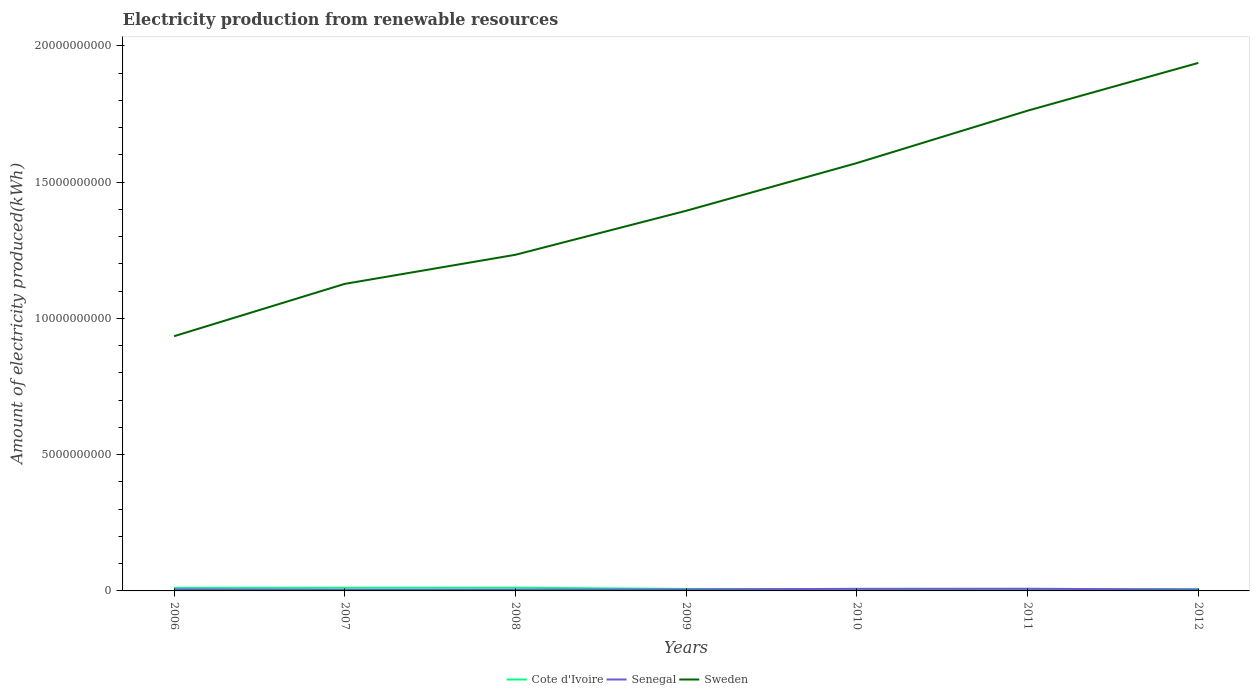How many different coloured lines are there?
Give a very brief answer. 3. Across all years, what is the maximum amount of electricity produced in Senegal?
Your response must be concise. 4.00e+07. In which year was the amount of electricity produced in Senegal maximum?
Provide a short and direct response. 2007. What is the total amount of electricity produced in Sweden in the graph?
Your answer should be very brief. -3.68e+09. What is the difference between the highest and the second highest amount of electricity produced in Senegal?
Offer a terse response. 4.00e+07. What is the difference between the highest and the lowest amount of electricity produced in Cote d'Ivoire?
Provide a short and direct response. 3. Is the amount of electricity produced in Sweden strictly greater than the amount of electricity produced in Cote d'Ivoire over the years?
Your response must be concise. No. How many years are there in the graph?
Offer a very short reply. 7. What is the difference between two consecutive major ticks on the Y-axis?
Provide a short and direct response. 5.00e+09. Are the values on the major ticks of Y-axis written in scientific E-notation?
Make the answer very short. No. What is the title of the graph?
Provide a short and direct response. Electricity production from renewable resources. What is the label or title of the Y-axis?
Provide a short and direct response. Amount of electricity produced(kWh). What is the Amount of electricity produced(kWh) of Cote d'Ivoire in 2006?
Provide a short and direct response. 1.12e+08. What is the Amount of electricity produced(kWh) of Senegal in 2006?
Offer a very short reply. 5.50e+07. What is the Amount of electricity produced(kWh) in Sweden in 2006?
Give a very brief answer. 9.35e+09. What is the Amount of electricity produced(kWh) in Cote d'Ivoire in 2007?
Your response must be concise. 1.15e+08. What is the Amount of electricity produced(kWh) in Senegal in 2007?
Your answer should be compact. 4.00e+07. What is the Amount of electricity produced(kWh) of Sweden in 2007?
Your answer should be very brief. 1.13e+1. What is the Amount of electricity produced(kWh) in Cote d'Ivoire in 2008?
Provide a succinct answer. 1.18e+08. What is the Amount of electricity produced(kWh) in Senegal in 2008?
Your answer should be compact. 4.30e+07. What is the Amount of electricity produced(kWh) in Sweden in 2008?
Offer a terse response. 1.23e+1. What is the Amount of electricity produced(kWh) in Cote d'Ivoire in 2009?
Keep it short and to the point. 7.20e+07. What is the Amount of electricity produced(kWh) of Senegal in 2009?
Ensure brevity in your answer.  5.30e+07. What is the Amount of electricity produced(kWh) of Sweden in 2009?
Provide a short and direct response. 1.40e+1. What is the Amount of electricity produced(kWh) in Cote d'Ivoire in 2010?
Your answer should be very brief. 6.90e+07. What is the Amount of electricity produced(kWh) in Senegal in 2010?
Your response must be concise. 7.70e+07. What is the Amount of electricity produced(kWh) in Sweden in 2010?
Your answer should be very brief. 1.57e+1. What is the Amount of electricity produced(kWh) of Cote d'Ivoire in 2011?
Provide a succinct answer. 6.40e+07. What is the Amount of electricity produced(kWh) in Senegal in 2011?
Keep it short and to the point. 8.00e+07. What is the Amount of electricity produced(kWh) in Sweden in 2011?
Offer a terse response. 1.76e+1. What is the Amount of electricity produced(kWh) of Cote d'Ivoire in 2012?
Make the answer very short. 6.60e+07. What is the Amount of electricity produced(kWh) in Senegal in 2012?
Offer a terse response. 4.90e+07. What is the Amount of electricity produced(kWh) in Sweden in 2012?
Make the answer very short. 1.94e+1. Across all years, what is the maximum Amount of electricity produced(kWh) in Cote d'Ivoire?
Offer a very short reply. 1.18e+08. Across all years, what is the maximum Amount of electricity produced(kWh) in Senegal?
Your answer should be compact. 8.00e+07. Across all years, what is the maximum Amount of electricity produced(kWh) of Sweden?
Provide a short and direct response. 1.94e+1. Across all years, what is the minimum Amount of electricity produced(kWh) in Cote d'Ivoire?
Provide a succinct answer. 6.40e+07. Across all years, what is the minimum Amount of electricity produced(kWh) of Senegal?
Keep it short and to the point. 4.00e+07. Across all years, what is the minimum Amount of electricity produced(kWh) of Sweden?
Provide a short and direct response. 9.35e+09. What is the total Amount of electricity produced(kWh) in Cote d'Ivoire in the graph?
Keep it short and to the point. 6.16e+08. What is the total Amount of electricity produced(kWh) in Senegal in the graph?
Offer a very short reply. 3.97e+08. What is the total Amount of electricity produced(kWh) of Sweden in the graph?
Ensure brevity in your answer.  9.96e+1. What is the difference between the Amount of electricity produced(kWh) in Cote d'Ivoire in 2006 and that in 2007?
Your response must be concise. -3.00e+06. What is the difference between the Amount of electricity produced(kWh) in Senegal in 2006 and that in 2007?
Offer a very short reply. 1.50e+07. What is the difference between the Amount of electricity produced(kWh) of Sweden in 2006 and that in 2007?
Offer a very short reply. -1.92e+09. What is the difference between the Amount of electricity produced(kWh) in Cote d'Ivoire in 2006 and that in 2008?
Offer a terse response. -6.00e+06. What is the difference between the Amount of electricity produced(kWh) in Sweden in 2006 and that in 2008?
Give a very brief answer. -2.99e+09. What is the difference between the Amount of electricity produced(kWh) of Cote d'Ivoire in 2006 and that in 2009?
Provide a succinct answer. 4.00e+07. What is the difference between the Amount of electricity produced(kWh) in Senegal in 2006 and that in 2009?
Your answer should be very brief. 2.00e+06. What is the difference between the Amount of electricity produced(kWh) of Sweden in 2006 and that in 2009?
Offer a terse response. -4.60e+09. What is the difference between the Amount of electricity produced(kWh) in Cote d'Ivoire in 2006 and that in 2010?
Ensure brevity in your answer.  4.30e+07. What is the difference between the Amount of electricity produced(kWh) of Senegal in 2006 and that in 2010?
Your response must be concise. -2.20e+07. What is the difference between the Amount of electricity produced(kWh) of Sweden in 2006 and that in 2010?
Make the answer very short. -6.36e+09. What is the difference between the Amount of electricity produced(kWh) in Cote d'Ivoire in 2006 and that in 2011?
Offer a very short reply. 4.80e+07. What is the difference between the Amount of electricity produced(kWh) in Senegal in 2006 and that in 2011?
Provide a short and direct response. -2.50e+07. What is the difference between the Amount of electricity produced(kWh) of Sweden in 2006 and that in 2011?
Offer a very short reply. -8.28e+09. What is the difference between the Amount of electricity produced(kWh) in Cote d'Ivoire in 2006 and that in 2012?
Ensure brevity in your answer.  4.60e+07. What is the difference between the Amount of electricity produced(kWh) of Sweden in 2006 and that in 2012?
Ensure brevity in your answer.  -1.00e+1. What is the difference between the Amount of electricity produced(kWh) in Cote d'Ivoire in 2007 and that in 2008?
Give a very brief answer. -3.00e+06. What is the difference between the Amount of electricity produced(kWh) in Sweden in 2007 and that in 2008?
Provide a short and direct response. -1.07e+09. What is the difference between the Amount of electricity produced(kWh) in Cote d'Ivoire in 2007 and that in 2009?
Your response must be concise. 4.30e+07. What is the difference between the Amount of electricity produced(kWh) of Senegal in 2007 and that in 2009?
Your response must be concise. -1.30e+07. What is the difference between the Amount of electricity produced(kWh) of Sweden in 2007 and that in 2009?
Offer a very short reply. -2.68e+09. What is the difference between the Amount of electricity produced(kWh) of Cote d'Ivoire in 2007 and that in 2010?
Your answer should be compact. 4.60e+07. What is the difference between the Amount of electricity produced(kWh) in Senegal in 2007 and that in 2010?
Give a very brief answer. -3.70e+07. What is the difference between the Amount of electricity produced(kWh) of Sweden in 2007 and that in 2010?
Provide a succinct answer. -4.43e+09. What is the difference between the Amount of electricity produced(kWh) of Cote d'Ivoire in 2007 and that in 2011?
Provide a short and direct response. 5.10e+07. What is the difference between the Amount of electricity produced(kWh) of Senegal in 2007 and that in 2011?
Offer a terse response. -4.00e+07. What is the difference between the Amount of electricity produced(kWh) of Sweden in 2007 and that in 2011?
Your answer should be very brief. -6.36e+09. What is the difference between the Amount of electricity produced(kWh) in Cote d'Ivoire in 2007 and that in 2012?
Your response must be concise. 4.90e+07. What is the difference between the Amount of electricity produced(kWh) in Senegal in 2007 and that in 2012?
Provide a succinct answer. -9.00e+06. What is the difference between the Amount of electricity produced(kWh) in Sweden in 2007 and that in 2012?
Provide a short and direct response. -8.11e+09. What is the difference between the Amount of electricity produced(kWh) in Cote d'Ivoire in 2008 and that in 2009?
Your answer should be compact. 4.60e+07. What is the difference between the Amount of electricity produced(kWh) in Senegal in 2008 and that in 2009?
Make the answer very short. -1.00e+07. What is the difference between the Amount of electricity produced(kWh) of Sweden in 2008 and that in 2009?
Your response must be concise. -1.62e+09. What is the difference between the Amount of electricity produced(kWh) of Cote d'Ivoire in 2008 and that in 2010?
Offer a very short reply. 4.90e+07. What is the difference between the Amount of electricity produced(kWh) of Senegal in 2008 and that in 2010?
Offer a terse response. -3.40e+07. What is the difference between the Amount of electricity produced(kWh) in Sweden in 2008 and that in 2010?
Offer a terse response. -3.37e+09. What is the difference between the Amount of electricity produced(kWh) in Cote d'Ivoire in 2008 and that in 2011?
Ensure brevity in your answer.  5.40e+07. What is the difference between the Amount of electricity produced(kWh) in Senegal in 2008 and that in 2011?
Keep it short and to the point. -3.70e+07. What is the difference between the Amount of electricity produced(kWh) of Sweden in 2008 and that in 2011?
Your response must be concise. -5.29e+09. What is the difference between the Amount of electricity produced(kWh) of Cote d'Ivoire in 2008 and that in 2012?
Your response must be concise. 5.20e+07. What is the difference between the Amount of electricity produced(kWh) of Senegal in 2008 and that in 2012?
Make the answer very short. -6.00e+06. What is the difference between the Amount of electricity produced(kWh) of Sweden in 2008 and that in 2012?
Provide a short and direct response. -7.04e+09. What is the difference between the Amount of electricity produced(kWh) of Cote d'Ivoire in 2009 and that in 2010?
Give a very brief answer. 3.00e+06. What is the difference between the Amount of electricity produced(kWh) of Senegal in 2009 and that in 2010?
Offer a terse response. -2.40e+07. What is the difference between the Amount of electricity produced(kWh) of Sweden in 2009 and that in 2010?
Ensure brevity in your answer.  -1.75e+09. What is the difference between the Amount of electricity produced(kWh) of Cote d'Ivoire in 2009 and that in 2011?
Provide a succinct answer. 8.00e+06. What is the difference between the Amount of electricity produced(kWh) in Senegal in 2009 and that in 2011?
Your answer should be compact. -2.70e+07. What is the difference between the Amount of electricity produced(kWh) of Sweden in 2009 and that in 2011?
Give a very brief answer. -3.67e+09. What is the difference between the Amount of electricity produced(kWh) of Senegal in 2009 and that in 2012?
Your answer should be compact. 4.00e+06. What is the difference between the Amount of electricity produced(kWh) in Sweden in 2009 and that in 2012?
Your response must be concise. -5.43e+09. What is the difference between the Amount of electricity produced(kWh) of Cote d'Ivoire in 2010 and that in 2011?
Ensure brevity in your answer.  5.00e+06. What is the difference between the Amount of electricity produced(kWh) in Senegal in 2010 and that in 2011?
Provide a succinct answer. -3.00e+06. What is the difference between the Amount of electricity produced(kWh) of Sweden in 2010 and that in 2011?
Offer a very short reply. -1.92e+09. What is the difference between the Amount of electricity produced(kWh) in Senegal in 2010 and that in 2012?
Your answer should be very brief. 2.80e+07. What is the difference between the Amount of electricity produced(kWh) of Sweden in 2010 and that in 2012?
Provide a short and direct response. -3.68e+09. What is the difference between the Amount of electricity produced(kWh) of Senegal in 2011 and that in 2012?
Ensure brevity in your answer.  3.10e+07. What is the difference between the Amount of electricity produced(kWh) of Sweden in 2011 and that in 2012?
Offer a very short reply. -1.75e+09. What is the difference between the Amount of electricity produced(kWh) of Cote d'Ivoire in 2006 and the Amount of electricity produced(kWh) of Senegal in 2007?
Your answer should be very brief. 7.20e+07. What is the difference between the Amount of electricity produced(kWh) of Cote d'Ivoire in 2006 and the Amount of electricity produced(kWh) of Sweden in 2007?
Offer a very short reply. -1.12e+1. What is the difference between the Amount of electricity produced(kWh) of Senegal in 2006 and the Amount of electricity produced(kWh) of Sweden in 2007?
Provide a succinct answer. -1.12e+1. What is the difference between the Amount of electricity produced(kWh) of Cote d'Ivoire in 2006 and the Amount of electricity produced(kWh) of Senegal in 2008?
Provide a succinct answer. 6.90e+07. What is the difference between the Amount of electricity produced(kWh) of Cote d'Ivoire in 2006 and the Amount of electricity produced(kWh) of Sweden in 2008?
Offer a terse response. -1.22e+1. What is the difference between the Amount of electricity produced(kWh) of Senegal in 2006 and the Amount of electricity produced(kWh) of Sweden in 2008?
Provide a succinct answer. -1.23e+1. What is the difference between the Amount of electricity produced(kWh) in Cote d'Ivoire in 2006 and the Amount of electricity produced(kWh) in Senegal in 2009?
Provide a short and direct response. 5.90e+07. What is the difference between the Amount of electricity produced(kWh) of Cote d'Ivoire in 2006 and the Amount of electricity produced(kWh) of Sweden in 2009?
Give a very brief answer. -1.38e+1. What is the difference between the Amount of electricity produced(kWh) of Senegal in 2006 and the Amount of electricity produced(kWh) of Sweden in 2009?
Your answer should be very brief. -1.39e+1. What is the difference between the Amount of electricity produced(kWh) in Cote d'Ivoire in 2006 and the Amount of electricity produced(kWh) in Senegal in 2010?
Your answer should be compact. 3.50e+07. What is the difference between the Amount of electricity produced(kWh) in Cote d'Ivoire in 2006 and the Amount of electricity produced(kWh) in Sweden in 2010?
Your answer should be compact. -1.56e+1. What is the difference between the Amount of electricity produced(kWh) of Senegal in 2006 and the Amount of electricity produced(kWh) of Sweden in 2010?
Make the answer very short. -1.56e+1. What is the difference between the Amount of electricity produced(kWh) of Cote d'Ivoire in 2006 and the Amount of electricity produced(kWh) of Senegal in 2011?
Offer a terse response. 3.20e+07. What is the difference between the Amount of electricity produced(kWh) of Cote d'Ivoire in 2006 and the Amount of electricity produced(kWh) of Sweden in 2011?
Keep it short and to the point. -1.75e+1. What is the difference between the Amount of electricity produced(kWh) in Senegal in 2006 and the Amount of electricity produced(kWh) in Sweden in 2011?
Provide a short and direct response. -1.76e+1. What is the difference between the Amount of electricity produced(kWh) of Cote d'Ivoire in 2006 and the Amount of electricity produced(kWh) of Senegal in 2012?
Your response must be concise. 6.30e+07. What is the difference between the Amount of electricity produced(kWh) of Cote d'Ivoire in 2006 and the Amount of electricity produced(kWh) of Sweden in 2012?
Provide a short and direct response. -1.93e+1. What is the difference between the Amount of electricity produced(kWh) in Senegal in 2006 and the Amount of electricity produced(kWh) in Sweden in 2012?
Your response must be concise. -1.93e+1. What is the difference between the Amount of electricity produced(kWh) in Cote d'Ivoire in 2007 and the Amount of electricity produced(kWh) in Senegal in 2008?
Ensure brevity in your answer.  7.20e+07. What is the difference between the Amount of electricity produced(kWh) in Cote d'Ivoire in 2007 and the Amount of electricity produced(kWh) in Sweden in 2008?
Provide a short and direct response. -1.22e+1. What is the difference between the Amount of electricity produced(kWh) in Senegal in 2007 and the Amount of electricity produced(kWh) in Sweden in 2008?
Ensure brevity in your answer.  -1.23e+1. What is the difference between the Amount of electricity produced(kWh) in Cote d'Ivoire in 2007 and the Amount of electricity produced(kWh) in Senegal in 2009?
Make the answer very short. 6.20e+07. What is the difference between the Amount of electricity produced(kWh) of Cote d'Ivoire in 2007 and the Amount of electricity produced(kWh) of Sweden in 2009?
Your answer should be very brief. -1.38e+1. What is the difference between the Amount of electricity produced(kWh) of Senegal in 2007 and the Amount of electricity produced(kWh) of Sweden in 2009?
Provide a short and direct response. -1.39e+1. What is the difference between the Amount of electricity produced(kWh) of Cote d'Ivoire in 2007 and the Amount of electricity produced(kWh) of Senegal in 2010?
Give a very brief answer. 3.80e+07. What is the difference between the Amount of electricity produced(kWh) of Cote d'Ivoire in 2007 and the Amount of electricity produced(kWh) of Sweden in 2010?
Keep it short and to the point. -1.56e+1. What is the difference between the Amount of electricity produced(kWh) of Senegal in 2007 and the Amount of electricity produced(kWh) of Sweden in 2010?
Keep it short and to the point. -1.57e+1. What is the difference between the Amount of electricity produced(kWh) in Cote d'Ivoire in 2007 and the Amount of electricity produced(kWh) in Senegal in 2011?
Your answer should be compact. 3.50e+07. What is the difference between the Amount of electricity produced(kWh) of Cote d'Ivoire in 2007 and the Amount of electricity produced(kWh) of Sweden in 2011?
Keep it short and to the point. -1.75e+1. What is the difference between the Amount of electricity produced(kWh) in Senegal in 2007 and the Amount of electricity produced(kWh) in Sweden in 2011?
Provide a succinct answer. -1.76e+1. What is the difference between the Amount of electricity produced(kWh) of Cote d'Ivoire in 2007 and the Amount of electricity produced(kWh) of Senegal in 2012?
Provide a short and direct response. 6.60e+07. What is the difference between the Amount of electricity produced(kWh) of Cote d'Ivoire in 2007 and the Amount of electricity produced(kWh) of Sweden in 2012?
Ensure brevity in your answer.  -1.93e+1. What is the difference between the Amount of electricity produced(kWh) of Senegal in 2007 and the Amount of electricity produced(kWh) of Sweden in 2012?
Your response must be concise. -1.93e+1. What is the difference between the Amount of electricity produced(kWh) of Cote d'Ivoire in 2008 and the Amount of electricity produced(kWh) of Senegal in 2009?
Provide a succinct answer. 6.50e+07. What is the difference between the Amount of electricity produced(kWh) in Cote d'Ivoire in 2008 and the Amount of electricity produced(kWh) in Sweden in 2009?
Your response must be concise. -1.38e+1. What is the difference between the Amount of electricity produced(kWh) in Senegal in 2008 and the Amount of electricity produced(kWh) in Sweden in 2009?
Offer a terse response. -1.39e+1. What is the difference between the Amount of electricity produced(kWh) of Cote d'Ivoire in 2008 and the Amount of electricity produced(kWh) of Senegal in 2010?
Your response must be concise. 4.10e+07. What is the difference between the Amount of electricity produced(kWh) in Cote d'Ivoire in 2008 and the Amount of electricity produced(kWh) in Sweden in 2010?
Offer a terse response. -1.56e+1. What is the difference between the Amount of electricity produced(kWh) in Senegal in 2008 and the Amount of electricity produced(kWh) in Sweden in 2010?
Make the answer very short. -1.57e+1. What is the difference between the Amount of electricity produced(kWh) of Cote d'Ivoire in 2008 and the Amount of electricity produced(kWh) of Senegal in 2011?
Offer a terse response. 3.80e+07. What is the difference between the Amount of electricity produced(kWh) of Cote d'Ivoire in 2008 and the Amount of electricity produced(kWh) of Sweden in 2011?
Give a very brief answer. -1.75e+1. What is the difference between the Amount of electricity produced(kWh) of Senegal in 2008 and the Amount of electricity produced(kWh) of Sweden in 2011?
Your answer should be very brief. -1.76e+1. What is the difference between the Amount of electricity produced(kWh) of Cote d'Ivoire in 2008 and the Amount of electricity produced(kWh) of Senegal in 2012?
Provide a short and direct response. 6.90e+07. What is the difference between the Amount of electricity produced(kWh) of Cote d'Ivoire in 2008 and the Amount of electricity produced(kWh) of Sweden in 2012?
Make the answer very short. -1.93e+1. What is the difference between the Amount of electricity produced(kWh) of Senegal in 2008 and the Amount of electricity produced(kWh) of Sweden in 2012?
Ensure brevity in your answer.  -1.93e+1. What is the difference between the Amount of electricity produced(kWh) of Cote d'Ivoire in 2009 and the Amount of electricity produced(kWh) of Senegal in 2010?
Ensure brevity in your answer.  -5.00e+06. What is the difference between the Amount of electricity produced(kWh) in Cote d'Ivoire in 2009 and the Amount of electricity produced(kWh) in Sweden in 2010?
Give a very brief answer. -1.56e+1. What is the difference between the Amount of electricity produced(kWh) of Senegal in 2009 and the Amount of electricity produced(kWh) of Sweden in 2010?
Ensure brevity in your answer.  -1.56e+1. What is the difference between the Amount of electricity produced(kWh) in Cote d'Ivoire in 2009 and the Amount of electricity produced(kWh) in Senegal in 2011?
Keep it short and to the point. -8.00e+06. What is the difference between the Amount of electricity produced(kWh) in Cote d'Ivoire in 2009 and the Amount of electricity produced(kWh) in Sweden in 2011?
Offer a terse response. -1.76e+1. What is the difference between the Amount of electricity produced(kWh) in Senegal in 2009 and the Amount of electricity produced(kWh) in Sweden in 2011?
Provide a short and direct response. -1.76e+1. What is the difference between the Amount of electricity produced(kWh) in Cote d'Ivoire in 2009 and the Amount of electricity produced(kWh) in Senegal in 2012?
Offer a terse response. 2.30e+07. What is the difference between the Amount of electricity produced(kWh) in Cote d'Ivoire in 2009 and the Amount of electricity produced(kWh) in Sweden in 2012?
Give a very brief answer. -1.93e+1. What is the difference between the Amount of electricity produced(kWh) in Senegal in 2009 and the Amount of electricity produced(kWh) in Sweden in 2012?
Your response must be concise. -1.93e+1. What is the difference between the Amount of electricity produced(kWh) in Cote d'Ivoire in 2010 and the Amount of electricity produced(kWh) in Senegal in 2011?
Give a very brief answer. -1.10e+07. What is the difference between the Amount of electricity produced(kWh) of Cote d'Ivoire in 2010 and the Amount of electricity produced(kWh) of Sweden in 2011?
Provide a succinct answer. -1.76e+1. What is the difference between the Amount of electricity produced(kWh) in Senegal in 2010 and the Amount of electricity produced(kWh) in Sweden in 2011?
Your answer should be very brief. -1.75e+1. What is the difference between the Amount of electricity produced(kWh) of Cote d'Ivoire in 2010 and the Amount of electricity produced(kWh) of Senegal in 2012?
Provide a succinct answer. 2.00e+07. What is the difference between the Amount of electricity produced(kWh) of Cote d'Ivoire in 2010 and the Amount of electricity produced(kWh) of Sweden in 2012?
Provide a short and direct response. -1.93e+1. What is the difference between the Amount of electricity produced(kWh) of Senegal in 2010 and the Amount of electricity produced(kWh) of Sweden in 2012?
Offer a very short reply. -1.93e+1. What is the difference between the Amount of electricity produced(kWh) of Cote d'Ivoire in 2011 and the Amount of electricity produced(kWh) of Senegal in 2012?
Your response must be concise. 1.50e+07. What is the difference between the Amount of electricity produced(kWh) in Cote d'Ivoire in 2011 and the Amount of electricity produced(kWh) in Sweden in 2012?
Your answer should be compact. -1.93e+1. What is the difference between the Amount of electricity produced(kWh) in Senegal in 2011 and the Amount of electricity produced(kWh) in Sweden in 2012?
Provide a short and direct response. -1.93e+1. What is the average Amount of electricity produced(kWh) in Cote d'Ivoire per year?
Provide a short and direct response. 8.80e+07. What is the average Amount of electricity produced(kWh) of Senegal per year?
Your response must be concise. 5.67e+07. What is the average Amount of electricity produced(kWh) of Sweden per year?
Offer a terse response. 1.42e+1. In the year 2006, what is the difference between the Amount of electricity produced(kWh) in Cote d'Ivoire and Amount of electricity produced(kWh) in Senegal?
Offer a very short reply. 5.70e+07. In the year 2006, what is the difference between the Amount of electricity produced(kWh) in Cote d'Ivoire and Amount of electricity produced(kWh) in Sweden?
Provide a succinct answer. -9.24e+09. In the year 2006, what is the difference between the Amount of electricity produced(kWh) in Senegal and Amount of electricity produced(kWh) in Sweden?
Make the answer very short. -9.29e+09. In the year 2007, what is the difference between the Amount of electricity produced(kWh) in Cote d'Ivoire and Amount of electricity produced(kWh) in Senegal?
Your answer should be very brief. 7.50e+07. In the year 2007, what is the difference between the Amount of electricity produced(kWh) of Cote d'Ivoire and Amount of electricity produced(kWh) of Sweden?
Provide a short and direct response. -1.12e+1. In the year 2007, what is the difference between the Amount of electricity produced(kWh) in Senegal and Amount of electricity produced(kWh) in Sweden?
Keep it short and to the point. -1.12e+1. In the year 2008, what is the difference between the Amount of electricity produced(kWh) in Cote d'Ivoire and Amount of electricity produced(kWh) in Senegal?
Your response must be concise. 7.50e+07. In the year 2008, what is the difference between the Amount of electricity produced(kWh) in Cote d'Ivoire and Amount of electricity produced(kWh) in Sweden?
Your answer should be very brief. -1.22e+1. In the year 2008, what is the difference between the Amount of electricity produced(kWh) of Senegal and Amount of electricity produced(kWh) of Sweden?
Offer a very short reply. -1.23e+1. In the year 2009, what is the difference between the Amount of electricity produced(kWh) of Cote d'Ivoire and Amount of electricity produced(kWh) of Senegal?
Offer a terse response. 1.90e+07. In the year 2009, what is the difference between the Amount of electricity produced(kWh) of Cote d'Ivoire and Amount of electricity produced(kWh) of Sweden?
Give a very brief answer. -1.39e+1. In the year 2009, what is the difference between the Amount of electricity produced(kWh) of Senegal and Amount of electricity produced(kWh) of Sweden?
Provide a succinct answer. -1.39e+1. In the year 2010, what is the difference between the Amount of electricity produced(kWh) of Cote d'Ivoire and Amount of electricity produced(kWh) of Senegal?
Offer a terse response. -8.00e+06. In the year 2010, what is the difference between the Amount of electricity produced(kWh) of Cote d'Ivoire and Amount of electricity produced(kWh) of Sweden?
Your answer should be very brief. -1.56e+1. In the year 2010, what is the difference between the Amount of electricity produced(kWh) of Senegal and Amount of electricity produced(kWh) of Sweden?
Offer a very short reply. -1.56e+1. In the year 2011, what is the difference between the Amount of electricity produced(kWh) of Cote d'Ivoire and Amount of electricity produced(kWh) of Senegal?
Provide a succinct answer. -1.60e+07. In the year 2011, what is the difference between the Amount of electricity produced(kWh) in Cote d'Ivoire and Amount of electricity produced(kWh) in Sweden?
Ensure brevity in your answer.  -1.76e+1. In the year 2011, what is the difference between the Amount of electricity produced(kWh) in Senegal and Amount of electricity produced(kWh) in Sweden?
Offer a terse response. -1.75e+1. In the year 2012, what is the difference between the Amount of electricity produced(kWh) of Cote d'Ivoire and Amount of electricity produced(kWh) of Senegal?
Give a very brief answer. 1.70e+07. In the year 2012, what is the difference between the Amount of electricity produced(kWh) in Cote d'Ivoire and Amount of electricity produced(kWh) in Sweden?
Your answer should be compact. -1.93e+1. In the year 2012, what is the difference between the Amount of electricity produced(kWh) of Senegal and Amount of electricity produced(kWh) of Sweden?
Your answer should be very brief. -1.93e+1. What is the ratio of the Amount of electricity produced(kWh) of Cote d'Ivoire in 2006 to that in 2007?
Make the answer very short. 0.97. What is the ratio of the Amount of electricity produced(kWh) of Senegal in 2006 to that in 2007?
Ensure brevity in your answer.  1.38. What is the ratio of the Amount of electricity produced(kWh) in Sweden in 2006 to that in 2007?
Provide a short and direct response. 0.83. What is the ratio of the Amount of electricity produced(kWh) in Cote d'Ivoire in 2006 to that in 2008?
Offer a terse response. 0.95. What is the ratio of the Amount of electricity produced(kWh) of Senegal in 2006 to that in 2008?
Your answer should be very brief. 1.28. What is the ratio of the Amount of electricity produced(kWh) of Sweden in 2006 to that in 2008?
Your response must be concise. 0.76. What is the ratio of the Amount of electricity produced(kWh) of Cote d'Ivoire in 2006 to that in 2009?
Provide a succinct answer. 1.56. What is the ratio of the Amount of electricity produced(kWh) of Senegal in 2006 to that in 2009?
Your response must be concise. 1.04. What is the ratio of the Amount of electricity produced(kWh) of Sweden in 2006 to that in 2009?
Provide a succinct answer. 0.67. What is the ratio of the Amount of electricity produced(kWh) of Cote d'Ivoire in 2006 to that in 2010?
Provide a short and direct response. 1.62. What is the ratio of the Amount of electricity produced(kWh) in Senegal in 2006 to that in 2010?
Offer a very short reply. 0.71. What is the ratio of the Amount of electricity produced(kWh) in Sweden in 2006 to that in 2010?
Offer a very short reply. 0.6. What is the ratio of the Amount of electricity produced(kWh) of Senegal in 2006 to that in 2011?
Ensure brevity in your answer.  0.69. What is the ratio of the Amount of electricity produced(kWh) in Sweden in 2006 to that in 2011?
Offer a very short reply. 0.53. What is the ratio of the Amount of electricity produced(kWh) in Cote d'Ivoire in 2006 to that in 2012?
Make the answer very short. 1.7. What is the ratio of the Amount of electricity produced(kWh) in Senegal in 2006 to that in 2012?
Make the answer very short. 1.12. What is the ratio of the Amount of electricity produced(kWh) of Sweden in 2006 to that in 2012?
Give a very brief answer. 0.48. What is the ratio of the Amount of electricity produced(kWh) of Cote d'Ivoire in 2007 to that in 2008?
Provide a short and direct response. 0.97. What is the ratio of the Amount of electricity produced(kWh) in Senegal in 2007 to that in 2008?
Keep it short and to the point. 0.93. What is the ratio of the Amount of electricity produced(kWh) in Sweden in 2007 to that in 2008?
Offer a very short reply. 0.91. What is the ratio of the Amount of electricity produced(kWh) in Cote d'Ivoire in 2007 to that in 2009?
Provide a succinct answer. 1.6. What is the ratio of the Amount of electricity produced(kWh) in Senegal in 2007 to that in 2009?
Your answer should be compact. 0.75. What is the ratio of the Amount of electricity produced(kWh) of Sweden in 2007 to that in 2009?
Your answer should be compact. 0.81. What is the ratio of the Amount of electricity produced(kWh) of Senegal in 2007 to that in 2010?
Your answer should be very brief. 0.52. What is the ratio of the Amount of electricity produced(kWh) in Sweden in 2007 to that in 2010?
Give a very brief answer. 0.72. What is the ratio of the Amount of electricity produced(kWh) in Cote d'Ivoire in 2007 to that in 2011?
Your answer should be compact. 1.8. What is the ratio of the Amount of electricity produced(kWh) of Sweden in 2007 to that in 2011?
Offer a terse response. 0.64. What is the ratio of the Amount of electricity produced(kWh) in Cote d'Ivoire in 2007 to that in 2012?
Provide a short and direct response. 1.74. What is the ratio of the Amount of electricity produced(kWh) of Senegal in 2007 to that in 2012?
Your answer should be compact. 0.82. What is the ratio of the Amount of electricity produced(kWh) in Sweden in 2007 to that in 2012?
Your answer should be very brief. 0.58. What is the ratio of the Amount of electricity produced(kWh) in Cote d'Ivoire in 2008 to that in 2009?
Give a very brief answer. 1.64. What is the ratio of the Amount of electricity produced(kWh) of Senegal in 2008 to that in 2009?
Provide a short and direct response. 0.81. What is the ratio of the Amount of electricity produced(kWh) in Sweden in 2008 to that in 2009?
Offer a very short reply. 0.88. What is the ratio of the Amount of electricity produced(kWh) of Cote d'Ivoire in 2008 to that in 2010?
Keep it short and to the point. 1.71. What is the ratio of the Amount of electricity produced(kWh) in Senegal in 2008 to that in 2010?
Make the answer very short. 0.56. What is the ratio of the Amount of electricity produced(kWh) in Sweden in 2008 to that in 2010?
Offer a very short reply. 0.79. What is the ratio of the Amount of electricity produced(kWh) in Cote d'Ivoire in 2008 to that in 2011?
Make the answer very short. 1.84. What is the ratio of the Amount of electricity produced(kWh) of Senegal in 2008 to that in 2011?
Keep it short and to the point. 0.54. What is the ratio of the Amount of electricity produced(kWh) in Cote d'Ivoire in 2008 to that in 2012?
Your answer should be compact. 1.79. What is the ratio of the Amount of electricity produced(kWh) in Senegal in 2008 to that in 2012?
Your answer should be compact. 0.88. What is the ratio of the Amount of electricity produced(kWh) of Sweden in 2008 to that in 2012?
Your answer should be very brief. 0.64. What is the ratio of the Amount of electricity produced(kWh) in Cote d'Ivoire in 2009 to that in 2010?
Ensure brevity in your answer.  1.04. What is the ratio of the Amount of electricity produced(kWh) of Senegal in 2009 to that in 2010?
Offer a terse response. 0.69. What is the ratio of the Amount of electricity produced(kWh) of Sweden in 2009 to that in 2010?
Your answer should be very brief. 0.89. What is the ratio of the Amount of electricity produced(kWh) of Cote d'Ivoire in 2009 to that in 2011?
Offer a terse response. 1.12. What is the ratio of the Amount of electricity produced(kWh) of Senegal in 2009 to that in 2011?
Your answer should be very brief. 0.66. What is the ratio of the Amount of electricity produced(kWh) of Sweden in 2009 to that in 2011?
Keep it short and to the point. 0.79. What is the ratio of the Amount of electricity produced(kWh) in Cote d'Ivoire in 2009 to that in 2012?
Your answer should be very brief. 1.09. What is the ratio of the Amount of electricity produced(kWh) in Senegal in 2009 to that in 2012?
Provide a short and direct response. 1.08. What is the ratio of the Amount of electricity produced(kWh) of Sweden in 2009 to that in 2012?
Keep it short and to the point. 0.72. What is the ratio of the Amount of electricity produced(kWh) in Cote d'Ivoire in 2010 to that in 2011?
Your answer should be very brief. 1.08. What is the ratio of the Amount of electricity produced(kWh) in Senegal in 2010 to that in 2011?
Your response must be concise. 0.96. What is the ratio of the Amount of electricity produced(kWh) in Sweden in 2010 to that in 2011?
Provide a short and direct response. 0.89. What is the ratio of the Amount of electricity produced(kWh) of Cote d'Ivoire in 2010 to that in 2012?
Offer a terse response. 1.05. What is the ratio of the Amount of electricity produced(kWh) in Senegal in 2010 to that in 2012?
Offer a very short reply. 1.57. What is the ratio of the Amount of electricity produced(kWh) in Sweden in 2010 to that in 2012?
Keep it short and to the point. 0.81. What is the ratio of the Amount of electricity produced(kWh) of Cote d'Ivoire in 2011 to that in 2012?
Your answer should be compact. 0.97. What is the ratio of the Amount of electricity produced(kWh) in Senegal in 2011 to that in 2012?
Give a very brief answer. 1.63. What is the ratio of the Amount of electricity produced(kWh) of Sweden in 2011 to that in 2012?
Your answer should be very brief. 0.91. What is the difference between the highest and the second highest Amount of electricity produced(kWh) of Sweden?
Ensure brevity in your answer.  1.75e+09. What is the difference between the highest and the lowest Amount of electricity produced(kWh) in Cote d'Ivoire?
Provide a succinct answer. 5.40e+07. What is the difference between the highest and the lowest Amount of electricity produced(kWh) in Senegal?
Offer a very short reply. 4.00e+07. What is the difference between the highest and the lowest Amount of electricity produced(kWh) in Sweden?
Keep it short and to the point. 1.00e+1. 